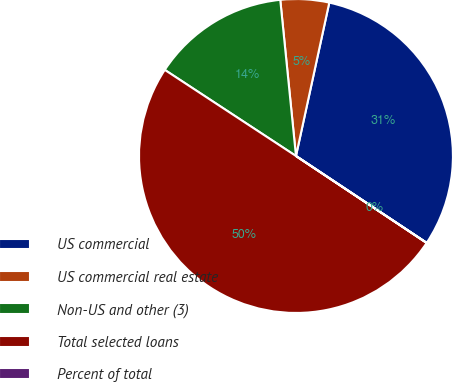Convert chart. <chart><loc_0><loc_0><loc_500><loc_500><pie_chart><fcel>US commercial<fcel>US commercial real estate<fcel>Non-US and other (3)<fcel>Total selected loans<fcel>Percent of total<nl><fcel>30.93%<fcel>5.0%<fcel>14.16%<fcel>49.9%<fcel>0.01%<nl></chart> 